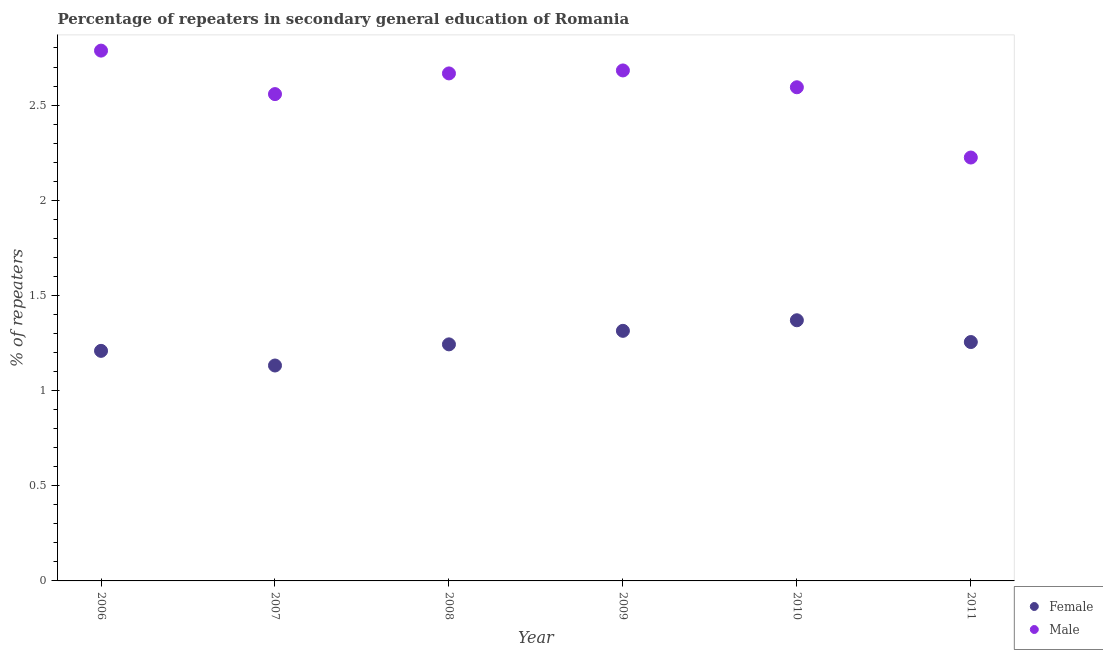How many different coloured dotlines are there?
Your answer should be very brief. 2. Is the number of dotlines equal to the number of legend labels?
Ensure brevity in your answer.  Yes. What is the percentage of male repeaters in 2010?
Your answer should be compact. 2.59. Across all years, what is the maximum percentage of female repeaters?
Ensure brevity in your answer.  1.37. Across all years, what is the minimum percentage of female repeaters?
Ensure brevity in your answer.  1.13. In which year was the percentage of female repeaters minimum?
Offer a very short reply. 2007. What is the total percentage of male repeaters in the graph?
Offer a very short reply. 15.51. What is the difference between the percentage of male repeaters in 2009 and that in 2011?
Provide a succinct answer. 0.46. What is the difference between the percentage of female repeaters in 2010 and the percentage of male repeaters in 2006?
Provide a succinct answer. -1.42. What is the average percentage of male repeaters per year?
Offer a terse response. 2.59. In the year 2010, what is the difference between the percentage of male repeaters and percentage of female repeaters?
Provide a short and direct response. 1.22. What is the ratio of the percentage of male repeaters in 2006 to that in 2011?
Ensure brevity in your answer.  1.25. Is the percentage of female repeaters in 2008 less than that in 2009?
Provide a succinct answer. Yes. Is the difference between the percentage of female repeaters in 2006 and 2010 greater than the difference between the percentage of male repeaters in 2006 and 2010?
Offer a very short reply. No. What is the difference between the highest and the second highest percentage of male repeaters?
Ensure brevity in your answer.  0.1. What is the difference between the highest and the lowest percentage of female repeaters?
Give a very brief answer. 0.24. In how many years, is the percentage of male repeaters greater than the average percentage of male repeaters taken over all years?
Keep it short and to the point. 4. Is the sum of the percentage of male repeaters in 2008 and 2011 greater than the maximum percentage of female repeaters across all years?
Offer a very short reply. Yes. Is the percentage of female repeaters strictly greater than the percentage of male repeaters over the years?
Ensure brevity in your answer.  No. How many dotlines are there?
Provide a succinct answer. 2. How many years are there in the graph?
Your answer should be very brief. 6. Does the graph contain grids?
Your answer should be compact. No. Where does the legend appear in the graph?
Provide a short and direct response. Bottom right. What is the title of the graph?
Make the answer very short. Percentage of repeaters in secondary general education of Romania. What is the label or title of the Y-axis?
Your answer should be compact. % of repeaters. What is the % of repeaters of Female in 2006?
Offer a terse response. 1.21. What is the % of repeaters of Male in 2006?
Your answer should be compact. 2.79. What is the % of repeaters of Female in 2007?
Offer a terse response. 1.13. What is the % of repeaters in Male in 2007?
Offer a very short reply. 2.56. What is the % of repeaters in Female in 2008?
Your answer should be compact. 1.24. What is the % of repeaters in Male in 2008?
Your answer should be very brief. 2.67. What is the % of repeaters of Female in 2009?
Offer a terse response. 1.31. What is the % of repeaters of Male in 2009?
Your response must be concise. 2.68. What is the % of repeaters in Female in 2010?
Your answer should be very brief. 1.37. What is the % of repeaters in Male in 2010?
Offer a very short reply. 2.59. What is the % of repeaters in Female in 2011?
Offer a terse response. 1.26. What is the % of repeaters of Male in 2011?
Ensure brevity in your answer.  2.22. Across all years, what is the maximum % of repeaters of Female?
Offer a terse response. 1.37. Across all years, what is the maximum % of repeaters of Male?
Offer a terse response. 2.79. Across all years, what is the minimum % of repeaters in Female?
Give a very brief answer. 1.13. Across all years, what is the minimum % of repeaters in Male?
Give a very brief answer. 2.22. What is the total % of repeaters in Female in the graph?
Provide a short and direct response. 7.52. What is the total % of repeaters in Male in the graph?
Provide a succinct answer. 15.51. What is the difference between the % of repeaters in Female in 2006 and that in 2007?
Keep it short and to the point. 0.08. What is the difference between the % of repeaters in Male in 2006 and that in 2007?
Keep it short and to the point. 0.23. What is the difference between the % of repeaters of Female in 2006 and that in 2008?
Your response must be concise. -0.03. What is the difference between the % of repeaters in Male in 2006 and that in 2008?
Offer a very short reply. 0.12. What is the difference between the % of repeaters of Female in 2006 and that in 2009?
Give a very brief answer. -0.11. What is the difference between the % of repeaters in Male in 2006 and that in 2009?
Provide a succinct answer. 0.1. What is the difference between the % of repeaters of Female in 2006 and that in 2010?
Provide a short and direct response. -0.16. What is the difference between the % of repeaters in Male in 2006 and that in 2010?
Provide a short and direct response. 0.19. What is the difference between the % of repeaters in Female in 2006 and that in 2011?
Provide a short and direct response. -0.05. What is the difference between the % of repeaters in Male in 2006 and that in 2011?
Ensure brevity in your answer.  0.56. What is the difference between the % of repeaters in Female in 2007 and that in 2008?
Your response must be concise. -0.11. What is the difference between the % of repeaters of Male in 2007 and that in 2008?
Give a very brief answer. -0.11. What is the difference between the % of repeaters in Female in 2007 and that in 2009?
Your answer should be very brief. -0.18. What is the difference between the % of repeaters of Male in 2007 and that in 2009?
Offer a very short reply. -0.12. What is the difference between the % of repeaters in Female in 2007 and that in 2010?
Keep it short and to the point. -0.24. What is the difference between the % of repeaters of Male in 2007 and that in 2010?
Offer a terse response. -0.04. What is the difference between the % of repeaters in Female in 2007 and that in 2011?
Provide a succinct answer. -0.12. What is the difference between the % of repeaters of Male in 2007 and that in 2011?
Offer a very short reply. 0.33. What is the difference between the % of repeaters of Female in 2008 and that in 2009?
Your answer should be very brief. -0.07. What is the difference between the % of repeaters of Male in 2008 and that in 2009?
Ensure brevity in your answer.  -0.02. What is the difference between the % of repeaters of Female in 2008 and that in 2010?
Your answer should be compact. -0.13. What is the difference between the % of repeaters in Male in 2008 and that in 2010?
Provide a short and direct response. 0.07. What is the difference between the % of repeaters of Female in 2008 and that in 2011?
Make the answer very short. -0.01. What is the difference between the % of repeaters in Male in 2008 and that in 2011?
Ensure brevity in your answer.  0.44. What is the difference between the % of repeaters in Female in 2009 and that in 2010?
Your response must be concise. -0.06. What is the difference between the % of repeaters of Male in 2009 and that in 2010?
Your response must be concise. 0.09. What is the difference between the % of repeaters of Female in 2009 and that in 2011?
Ensure brevity in your answer.  0.06. What is the difference between the % of repeaters in Male in 2009 and that in 2011?
Provide a succinct answer. 0.46. What is the difference between the % of repeaters of Female in 2010 and that in 2011?
Make the answer very short. 0.11. What is the difference between the % of repeaters in Male in 2010 and that in 2011?
Offer a very short reply. 0.37. What is the difference between the % of repeaters of Female in 2006 and the % of repeaters of Male in 2007?
Your response must be concise. -1.35. What is the difference between the % of repeaters of Female in 2006 and the % of repeaters of Male in 2008?
Your answer should be compact. -1.46. What is the difference between the % of repeaters in Female in 2006 and the % of repeaters in Male in 2009?
Your answer should be compact. -1.47. What is the difference between the % of repeaters of Female in 2006 and the % of repeaters of Male in 2010?
Offer a very short reply. -1.38. What is the difference between the % of repeaters of Female in 2006 and the % of repeaters of Male in 2011?
Your answer should be very brief. -1.02. What is the difference between the % of repeaters of Female in 2007 and the % of repeaters of Male in 2008?
Offer a very short reply. -1.53. What is the difference between the % of repeaters in Female in 2007 and the % of repeaters in Male in 2009?
Ensure brevity in your answer.  -1.55. What is the difference between the % of repeaters of Female in 2007 and the % of repeaters of Male in 2010?
Give a very brief answer. -1.46. What is the difference between the % of repeaters in Female in 2007 and the % of repeaters in Male in 2011?
Keep it short and to the point. -1.09. What is the difference between the % of repeaters in Female in 2008 and the % of repeaters in Male in 2009?
Offer a terse response. -1.44. What is the difference between the % of repeaters in Female in 2008 and the % of repeaters in Male in 2010?
Ensure brevity in your answer.  -1.35. What is the difference between the % of repeaters of Female in 2008 and the % of repeaters of Male in 2011?
Ensure brevity in your answer.  -0.98. What is the difference between the % of repeaters in Female in 2009 and the % of repeaters in Male in 2010?
Provide a short and direct response. -1.28. What is the difference between the % of repeaters of Female in 2009 and the % of repeaters of Male in 2011?
Offer a terse response. -0.91. What is the difference between the % of repeaters in Female in 2010 and the % of repeaters in Male in 2011?
Ensure brevity in your answer.  -0.85. What is the average % of repeaters in Female per year?
Keep it short and to the point. 1.25. What is the average % of repeaters of Male per year?
Your answer should be very brief. 2.58. In the year 2006, what is the difference between the % of repeaters in Female and % of repeaters in Male?
Give a very brief answer. -1.58. In the year 2007, what is the difference between the % of repeaters of Female and % of repeaters of Male?
Your response must be concise. -1.43. In the year 2008, what is the difference between the % of repeaters of Female and % of repeaters of Male?
Offer a terse response. -1.42. In the year 2009, what is the difference between the % of repeaters in Female and % of repeaters in Male?
Offer a terse response. -1.37. In the year 2010, what is the difference between the % of repeaters in Female and % of repeaters in Male?
Keep it short and to the point. -1.22. In the year 2011, what is the difference between the % of repeaters of Female and % of repeaters of Male?
Your answer should be very brief. -0.97. What is the ratio of the % of repeaters of Female in 2006 to that in 2007?
Your answer should be very brief. 1.07. What is the ratio of the % of repeaters in Male in 2006 to that in 2007?
Provide a short and direct response. 1.09. What is the ratio of the % of repeaters in Female in 2006 to that in 2008?
Your answer should be very brief. 0.97. What is the ratio of the % of repeaters in Male in 2006 to that in 2008?
Your answer should be compact. 1.04. What is the ratio of the % of repeaters in Female in 2006 to that in 2009?
Keep it short and to the point. 0.92. What is the ratio of the % of repeaters of Male in 2006 to that in 2009?
Your response must be concise. 1.04. What is the ratio of the % of repeaters of Female in 2006 to that in 2010?
Provide a short and direct response. 0.88. What is the ratio of the % of repeaters of Male in 2006 to that in 2010?
Provide a succinct answer. 1.07. What is the ratio of the % of repeaters of Female in 2006 to that in 2011?
Your answer should be very brief. 0.96. What is the ratio of the % of repeaters of Male in 2006 to that in 2011?
Your response must be concise. 1.25. What is the ratio of the % of repeaters of Female in 2007 to that in 2008?
Offer a terse response. 0.91. What is the ratio of the % of repeaters of Male in 2007 to that in 2008?
Give a very brief answer. 0.96. What is the ratio of the % of repeaters in Female in 2007 to that in 2009?
Your response must be concise. 0.86. What is the ratio of the % of repeaters in Male in 2007 to that in 2009?
Offer a very short reply. 0.95. What is the ratio of the % of repeaters in Female in 2007 to that in 2010?
Give a very brief answer. 0.83. What is the ratio of the % of repeaters of Male in 2007 to that in 2010?
Your answer should be very brief. 0.99. What is the ratio of the % of repeaters of Female in 2007 to that in 2011?
Give a very brief answer. 0.9. What is the ratio of the % of repeaters in Male in 2007 to that in 2011?
Give a very brief answer. 1.15. What is the ratio of the % of repeaters of Female in 2008 to that in 2009?
Offer a terse response. 0.95. What is the ratio of the % of repeaters in Female in 2008 to that in 2010?
Make the answer very short. 0.91. What is the ratio of the % of repeaters of Male in 2008 to that in 2010?
Provide a short and direct response. 1.03. What is the ratio of the % of repeaters of Female in 2008 to that in 2011?
Your answer should be very brief. 0.99. What is the ratio of the % of repeaters of Male in 2008 to that in 2011?
Ensure brevity in your answer.  1.2. What is the ratio of the % of repeaters in Female in 2009 to that in 2010?
Your answer should be very brief. 0.96. What is the ratio of the % of repeaters of Male in 2009 to that in 2010?
Provide a succinct answer. 1.03. What is the ratio of the % of repeaters of Female in 2009 to that in 2011?
Your response must be concise. 1.05. What is the ratio of the % of repeaters of Male in 2009 to that in 2011?
Ensure brevity in your answer.  1.21. What is the ratio of the % of repeaters of Female in 2010 to that in 2011?
Give a very brief answer. 1.09. What is the ratio of the % of repeaters of Male in 2010 to that in 2011?
Keep it short and to the point. 1.17. What is the difference between the highest and the second highest % of repeaters of Female?
Your answer should be compact. 0.06. What is the difference between the highest and the second highest % of repeaters of Male?
Give a very brief answer. 0.1. What is the difference between the highest and the lowest % of repeaters of Female?
Give a very brief answer. 0.24. What is the difference between the highest and the lowest % of repeaters in Male?
Your answer should be compact. 0.56. 